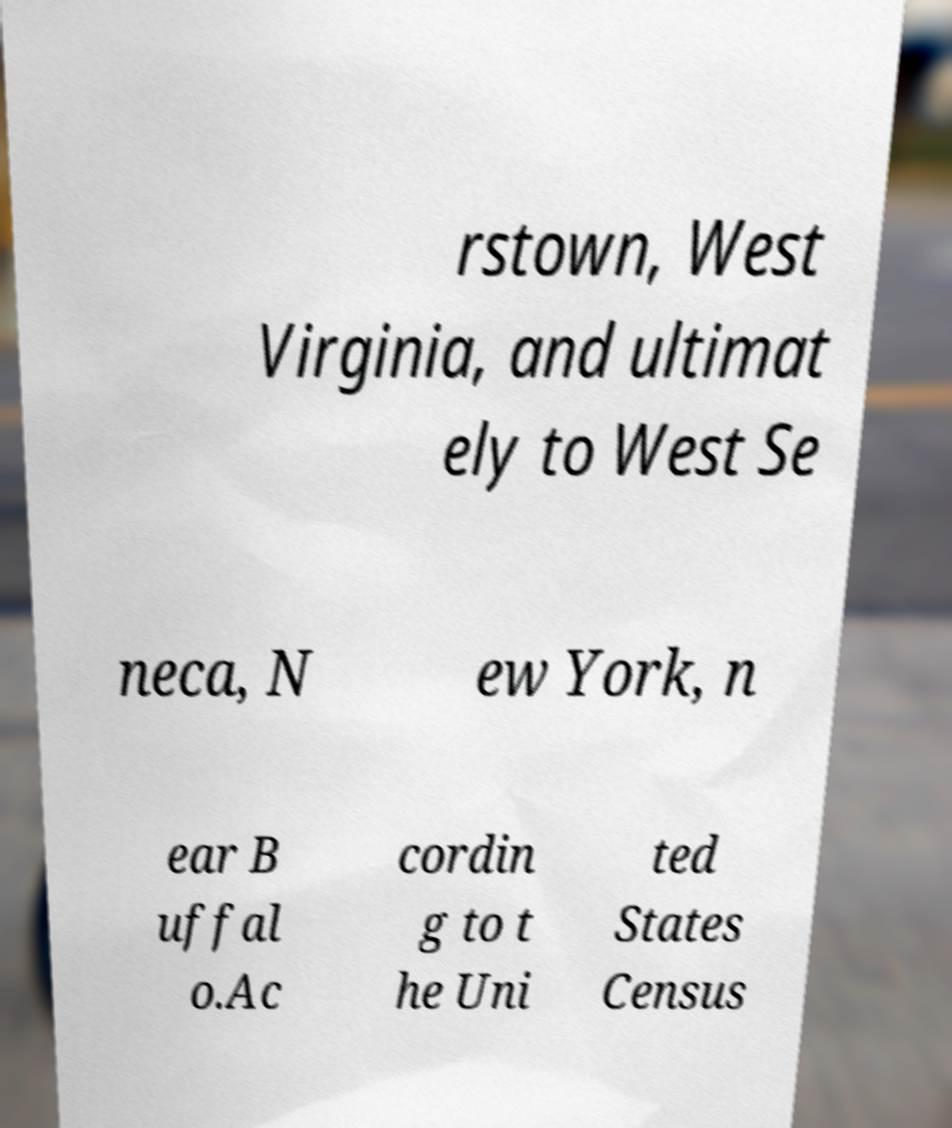For documentation purposes, I need the text within this image transcribed. Could you provide that? rstown, West Virginia, and ultimat ely to West Se neca, N ew York, n ear B uffal o.Ac cordin g to t he Uni ted States Census 